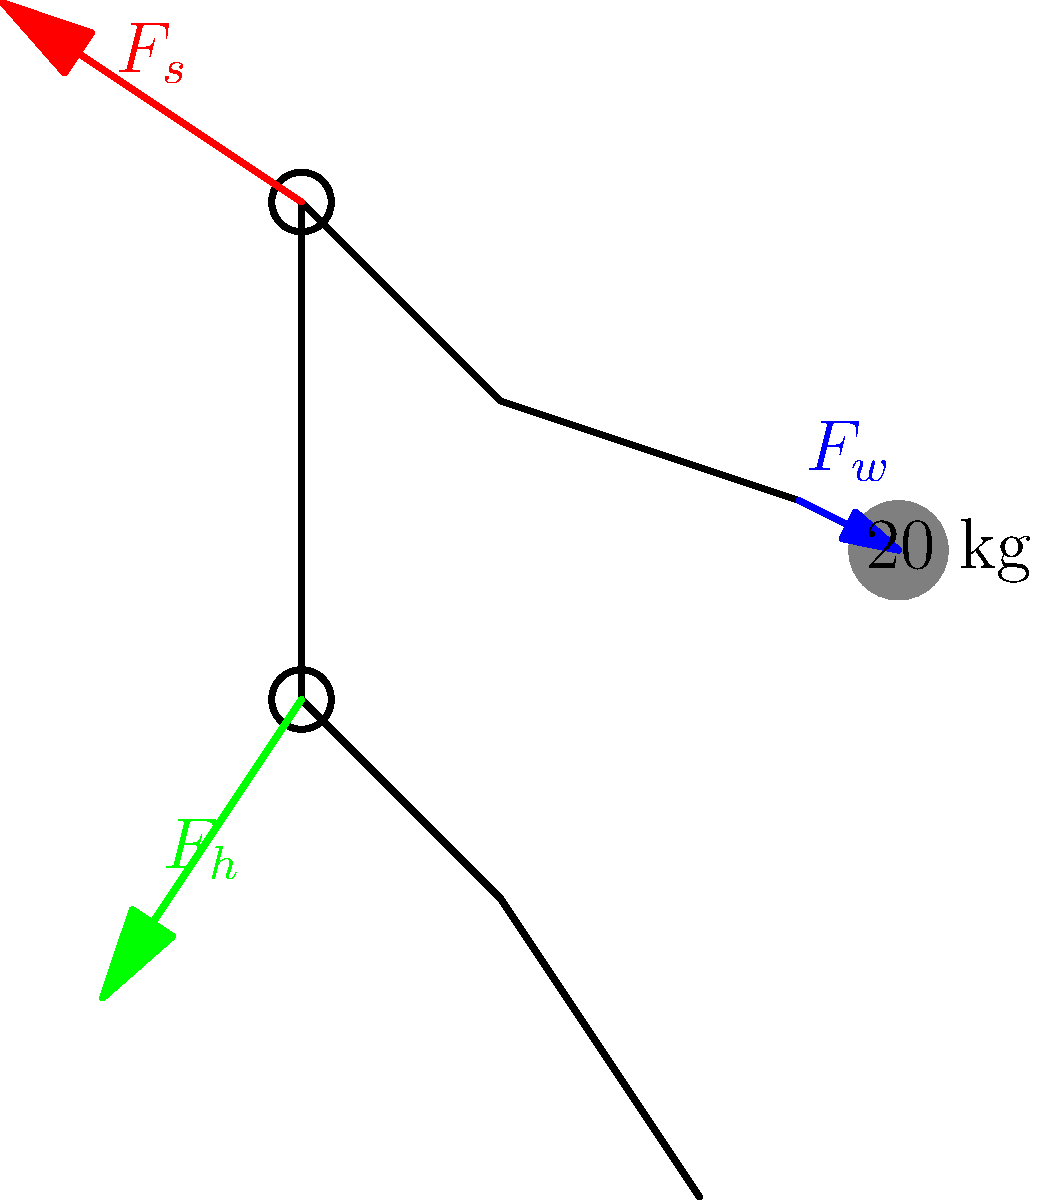A parent is demonstrating proper lifting techniques to their child who is interested in pursuing a career in physics. The parent lifts a 20 kg object as shown in the diagram. If the parent's upper arm makes a 30° angle with their torso and their forearm makes a 135° angle with their upper arm, calculate the magnitude of the force $F_s$ exerted by the shoulder joint to hold the weight in this static position. Assume the mass of the arm is negligible compared to the lifted weight. To solve this problem, we'll use the principles of static equilibrium and moment balance. Let's break it down step-by-step:

1) First, we need to identify the forces acting on the system:
   - The weight force ($F_w$) acting downward: $F_w = 20 \text{ kg} \times 9.8 \text{ m/s}^2 = 196 \text{ N}$
   - The shoulder force ($F_s$) acting upward and at an angle
   - The elbow joint force (not shown, but necessary for equilibrium)

2) We can treat the arm as a two-segment lever, with the shoulder as the fulcrum for the entire system.

3) The total length of the arm can be considered as the moment arm for the weight force. Let's call this length $L$.

4) The effective moment arm for the shoulder force will be $L \cos(165°)$, as the force is at a 165° angle to the horizontal (180° - 30° + 15°, where 15° is half of the 30° angle between the upper arm and torso).

5) Using the principle of moments, we can write:
   $F_s \times L \cos(165°) = F_w \times L$

6) The $L$ cancels out on both sides:
   $F_s \cos(165°) = F_w$

7) Rearranging to solve for $F_s$:
   $F_s = \frac{F_w}{\cos(165°)}$

8) Plugging in the values:
   $F_s = \frac{196 \text{ N}}{\cos(165°)} = \frac{196}{-0.9659} \approx 203 \text{ N}$

The negative cosine indicates that the force is in the opposite direction of the weight force, which makes sense as it's supporting the weight.
Answer: $F_s \approx 203 \text{ N}$ 